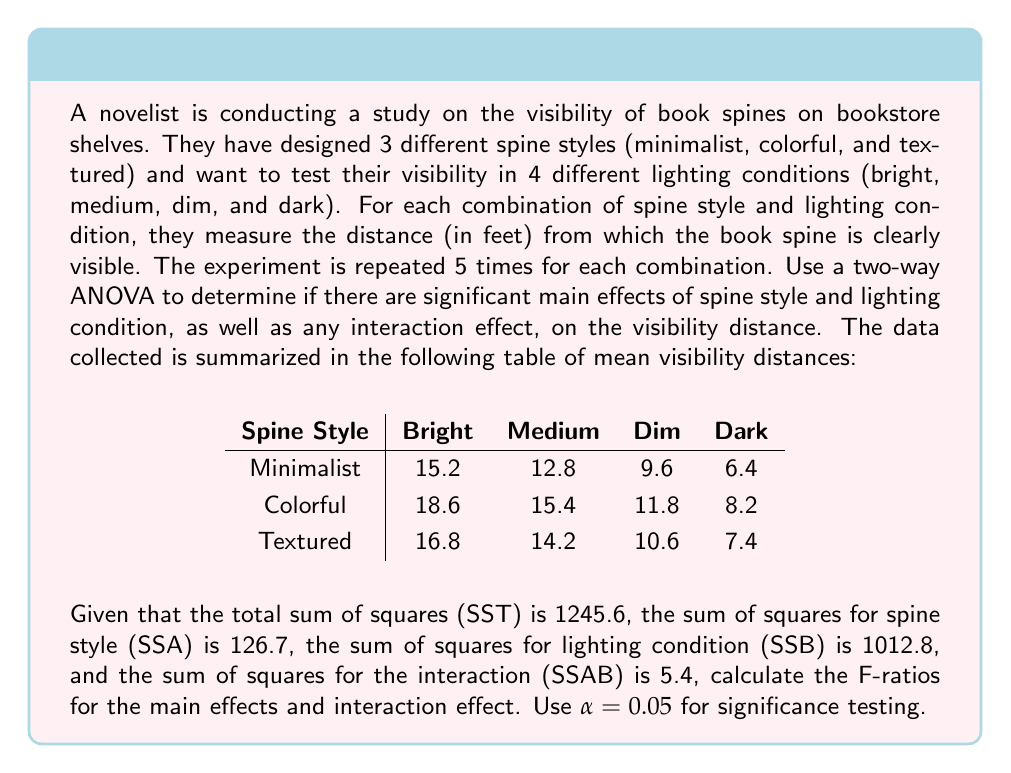Help me with this question. To solve this problem, we need to perform a two-way ANOVA. We'll calculate the F-ratios for the main effects (spine style and lighting condition) and the interaction effect. Then we'll compare these F-ratios to the critical F-values to determine significance.

Step 1: Identify the degrees of freedom (df)
- Spine style (Factor A): $df_A = 3 - 1 = 2$
- Lighting condition (Factor B): $df_B = 4 - 1 = 3$
- Interaction: $df_{AB} = df_A \times df_B = 2 \times 3 = 6$
- Total df: $N - 1 = (3 \times 4 \times 5) - 1 = 59$
- Error df: $df_E = 59 - 2 - 3 - 6 = 48$

Step 2: Calculate Mean Squares (MS)
$MS_A = \frac{SS_A}{df_A} = \frac{126.7}{2} = 63.35$
$MS_B = \frac{SS_B}{df_B} = \frac{1012.8}{3} = 337.60$
$MS_{AB} = \frac{SS_{AB}}{df_{AB}} = \frac{5.4}{6} = 0.90$
$MS_E = \frac{SS_E}{df_E} = \frac{1245.6 - 126.7 - 1012.8 - 5.4}{48} = \frac{100.7}{48} = 2.10$

Step 3: Calculate F-ratios
$F_A = \frac{MS_A}{MS_E} = \frac{63.35}{2.10} = 30.17$
$F_B = \frac{MS_B}{MS_E} = \frac{337.60}{2.10} = 160.76$
$F_{AB} = \frac{MS_{AB}}{MS_E} = \frac{0.90}{2.10} = 0.43$

Step 4: Determine critical F-values (α = 0.05)
$F_{crit(A)} = F_{0.05, 2, 48} \approx 3.19$
$F_{crit(B)} = F_{0.05, 3, 48} \approx 2.80$
$F_{crit(AB)} = F_{0.05, 6, 48} \approx 2.30$

Step 5: Compare F-ratios to critical F-values
- Spine style: $30.17 > 3.19$, so there is a significant main effect of spine style.
- Lighting condition: $160.76 > 2.80$, so there is a significant main effect of lighting condition.
- Interaction: $0.43 < 2.30$, so there is no significant interaction effect between spine style and lighting condition.
Answer: The F-ratios are:
Spine style (Factor A): $F_A = 30.17$
Lighting condition (Factor B): $F_B = 160.76$
Interaction: $F_{AB} = 0.43$

There are significant main effects of spine style and lighting condition on visibility distance (p < 0.05), but no significant interaction effect between spine style and lighting condition. 